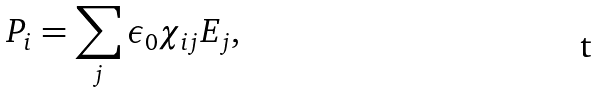Convert formula to latex. <formula><loc_0><loc_0><loc_500><loc_500>P _ { i } = \sum _ { j } \epsilon _ { 0 } \chi _ { i j } E _ { j } ,</formula> 